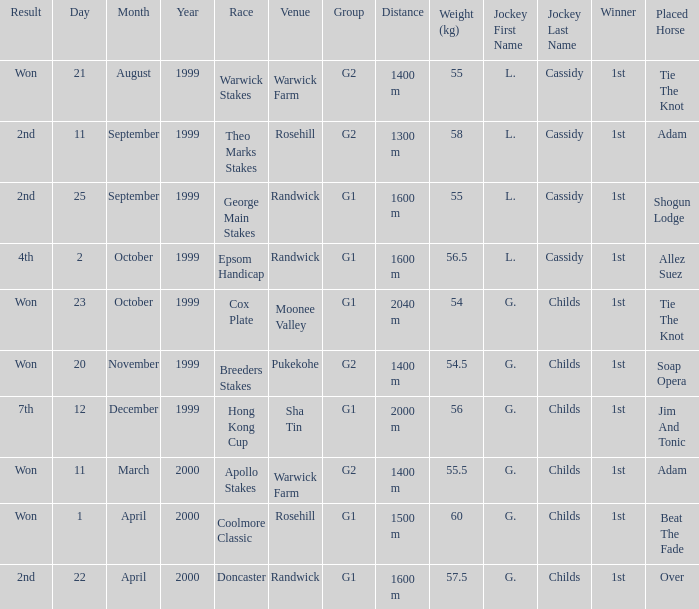How man teams had a total weight of 57.5? 1.0. 